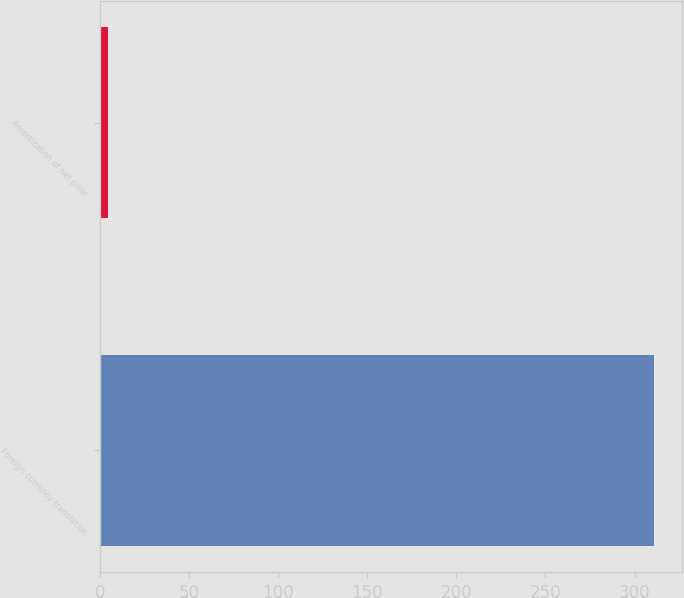<chart> <loc_0><loc_0><loc_500><loc_500><bar_chart><fcel>Foreign currency translation<fcel>Amortization of net prior<nl><fcel>310.9<fcel>4.7<nl></chart> 